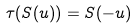<formula> <loc_0><loc_0><loc_500><loc_500>\tau ( S ( u ) ) = S ( - u )</formula> 